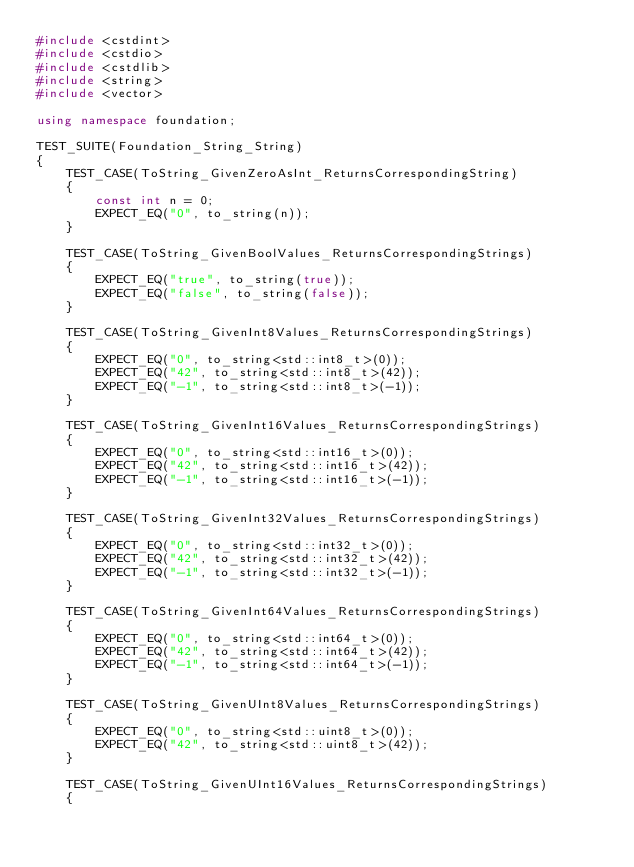Convert code to text. <code><loc_0><loc_0><loc_500><loc_500><_C++_>#include <cstdint>
#include <cstdio>
#include <cstdlib>
#include <string>
#include <vector>

using namespace foundation;

TEST_SUITE(Foundation_String_String)
{
    TEST_CASE(ToString_GivenZeroAsInt_ReturnsCorrespondingString)
    {
        const int n = 0;
        EXPECT_EQ("0", to_string(n));
    }

    TEST_CASE(ToString_GivenBoolValues_ReturnsCorrespondingStrings)
    {
        EXPECT_EQ("true", to_string(true));
        EXPECT_EQ("false", to_string(false));
    }

    TEST_CASE(ToString_GivenInt8Values_ReturnsCorrespondingStrings)
    {
        EXPECT_EQ("0", to_string<std::int8_t>(0));
        EXPECT_EQ("42", to_string<std::int8_t>(42));
        EXPECT_EQ("-1", to_string<std::int8_t>(-1));
    }

    TEST_CASE(ToString_GivenInt16Values_ReturnsCorrespondingStrings)
    {
        EXPECT_EQ("0", to_string<std::int16_t>(0));
        EXPECT_EQ("42", to_string<std::int16_t>(42));
        EXPECT_EQ("-1", to_string<std::int16_t>(-1));
    }

    TEST_CASE(ToString_GivenInt32Values_ReturnsCorrespondingStrings)
    {
        EXPECT_EQ("0", to_string<std::int32_t>(0));
        EXPECT_EQ("42", to_string<std::int32_t>(42));
        EXPECT_EQ("-1", to_string<std::int32_t>(-1));
    }

    TEST_CASE(ToString_GivenInt64Values_ReturnsCorrespondingStrings)
    {
        EXPECT_EQ("0", to_string<std::int64_t>(0));
        EXPECT_EQ("42", to_string<std::int64_t>(42));
        EXPECT_EQ("-1", to_string<std::int64_t>(-1));
    }

    TEST_CASE(ToString_GivenUInt8Values_ReturnsCorrespondingStrings)
    {
        EXPECT_EQ("0", to_string<std::uint8_t>(0));
        EXPECT_EQ("42", to_string<std::uint8_t>(42));
    }

    TEST_CASE(ToString_GivenUInt16Values_ReturnsCorrespondingStrings)
    {</code> 